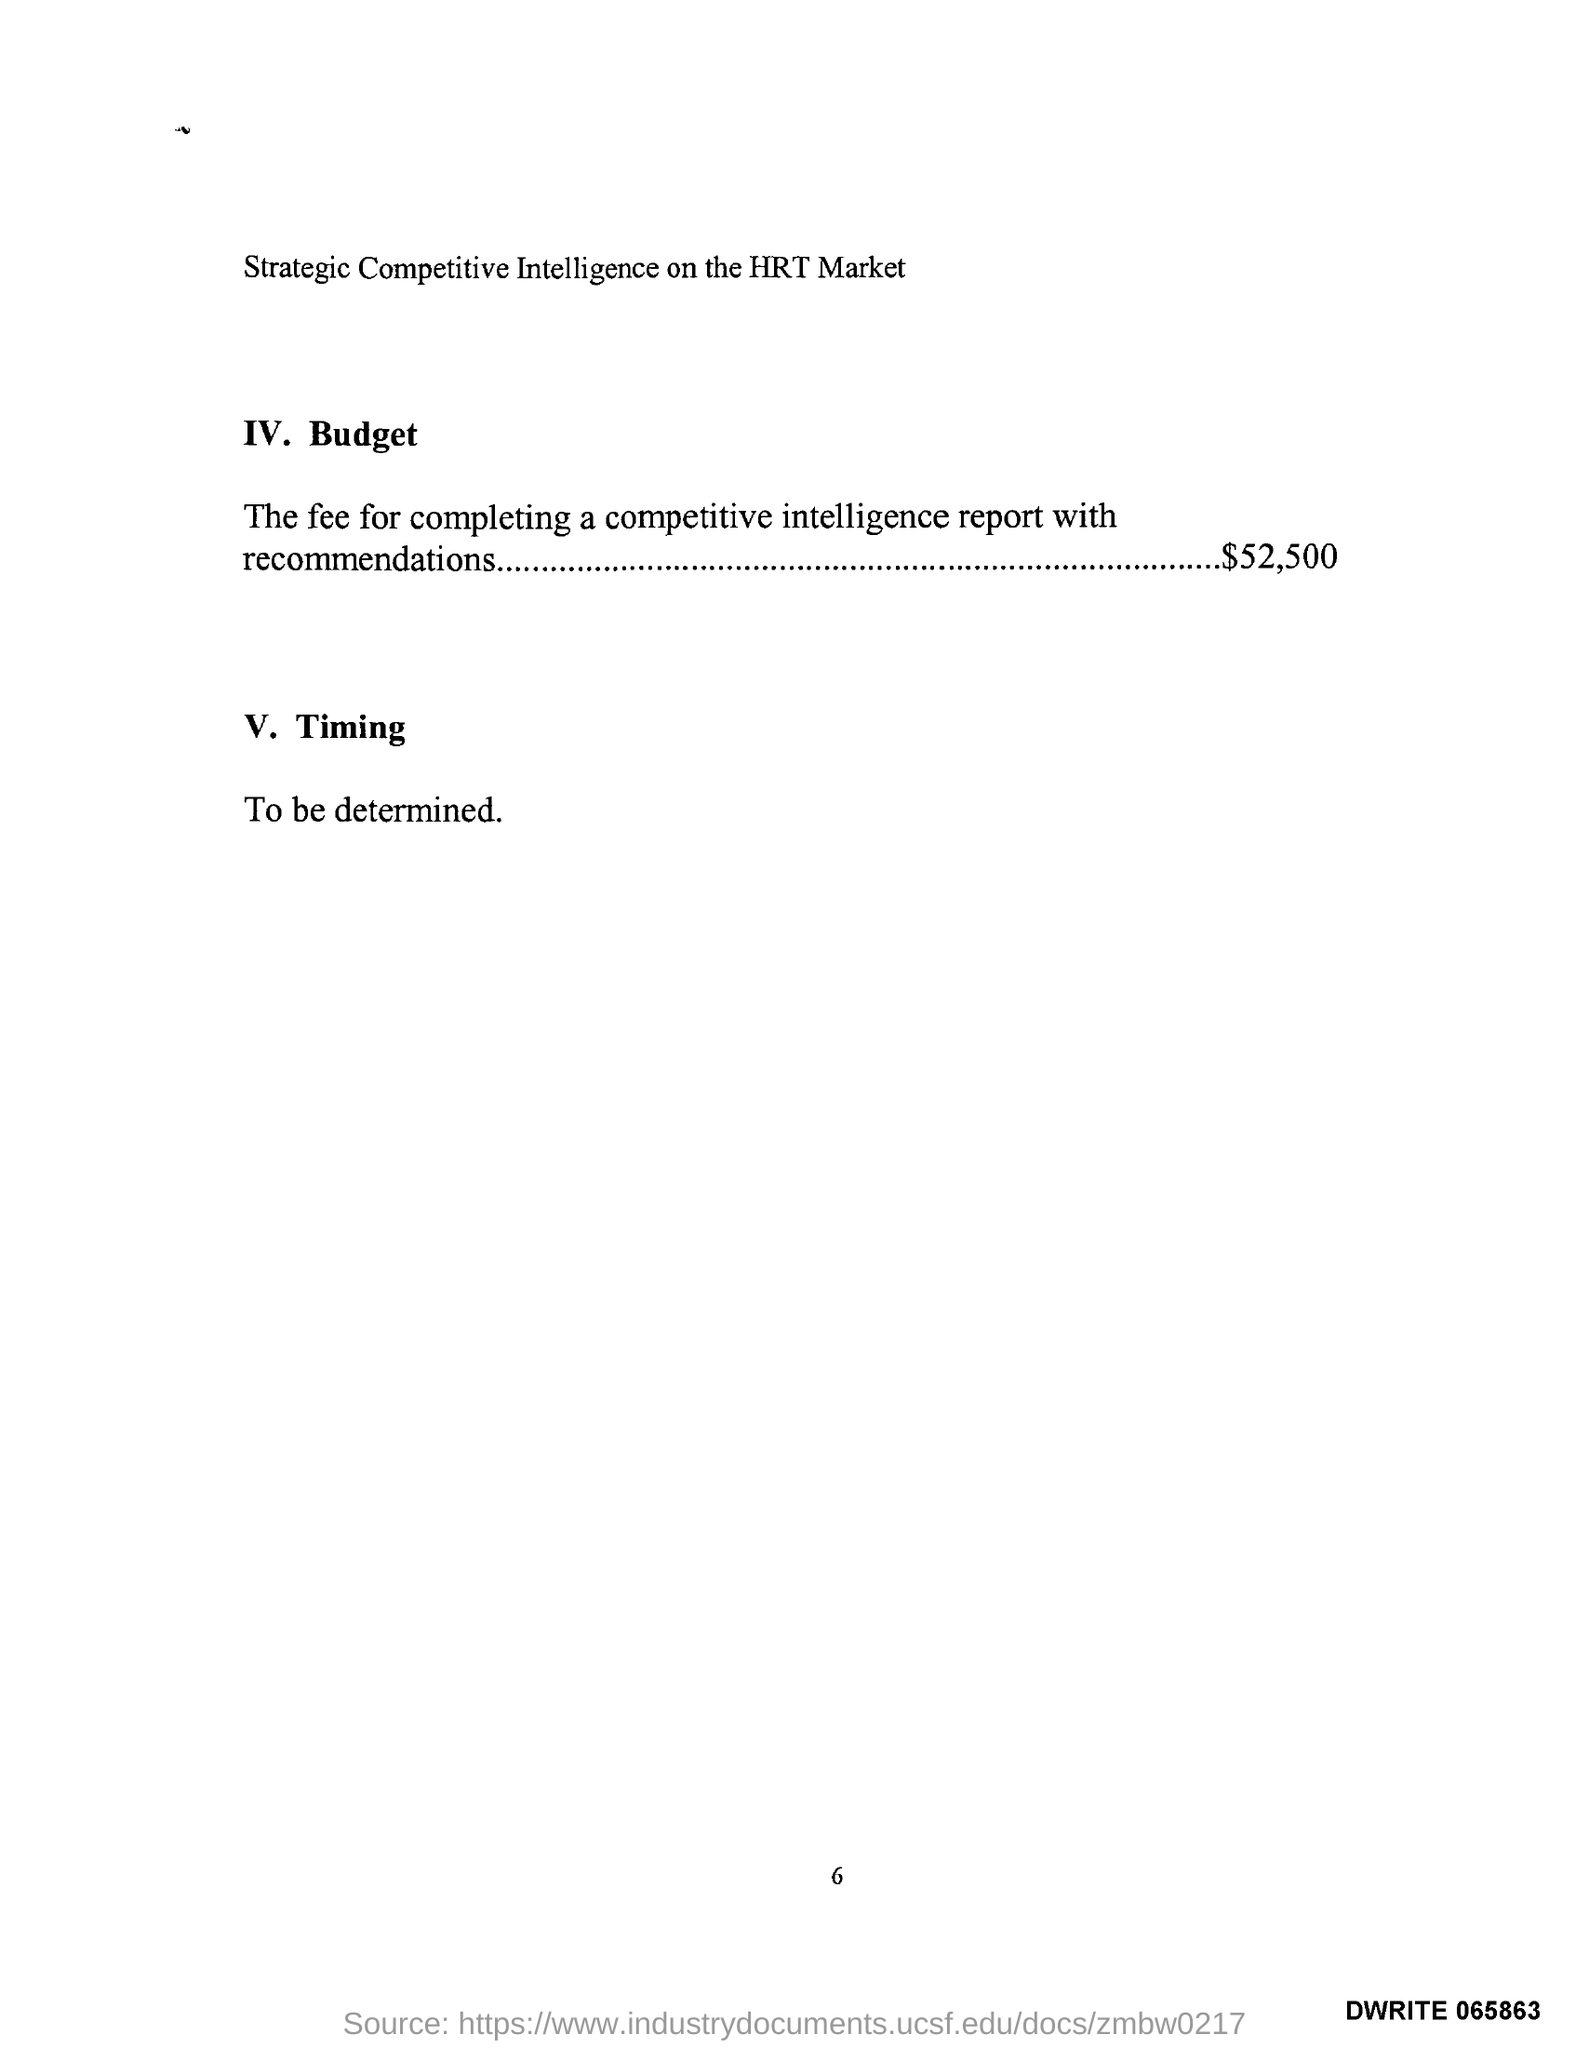Highlight a few significant elements in this photo. The description about timing is currently undetermined. The budget amount is $52,500. 